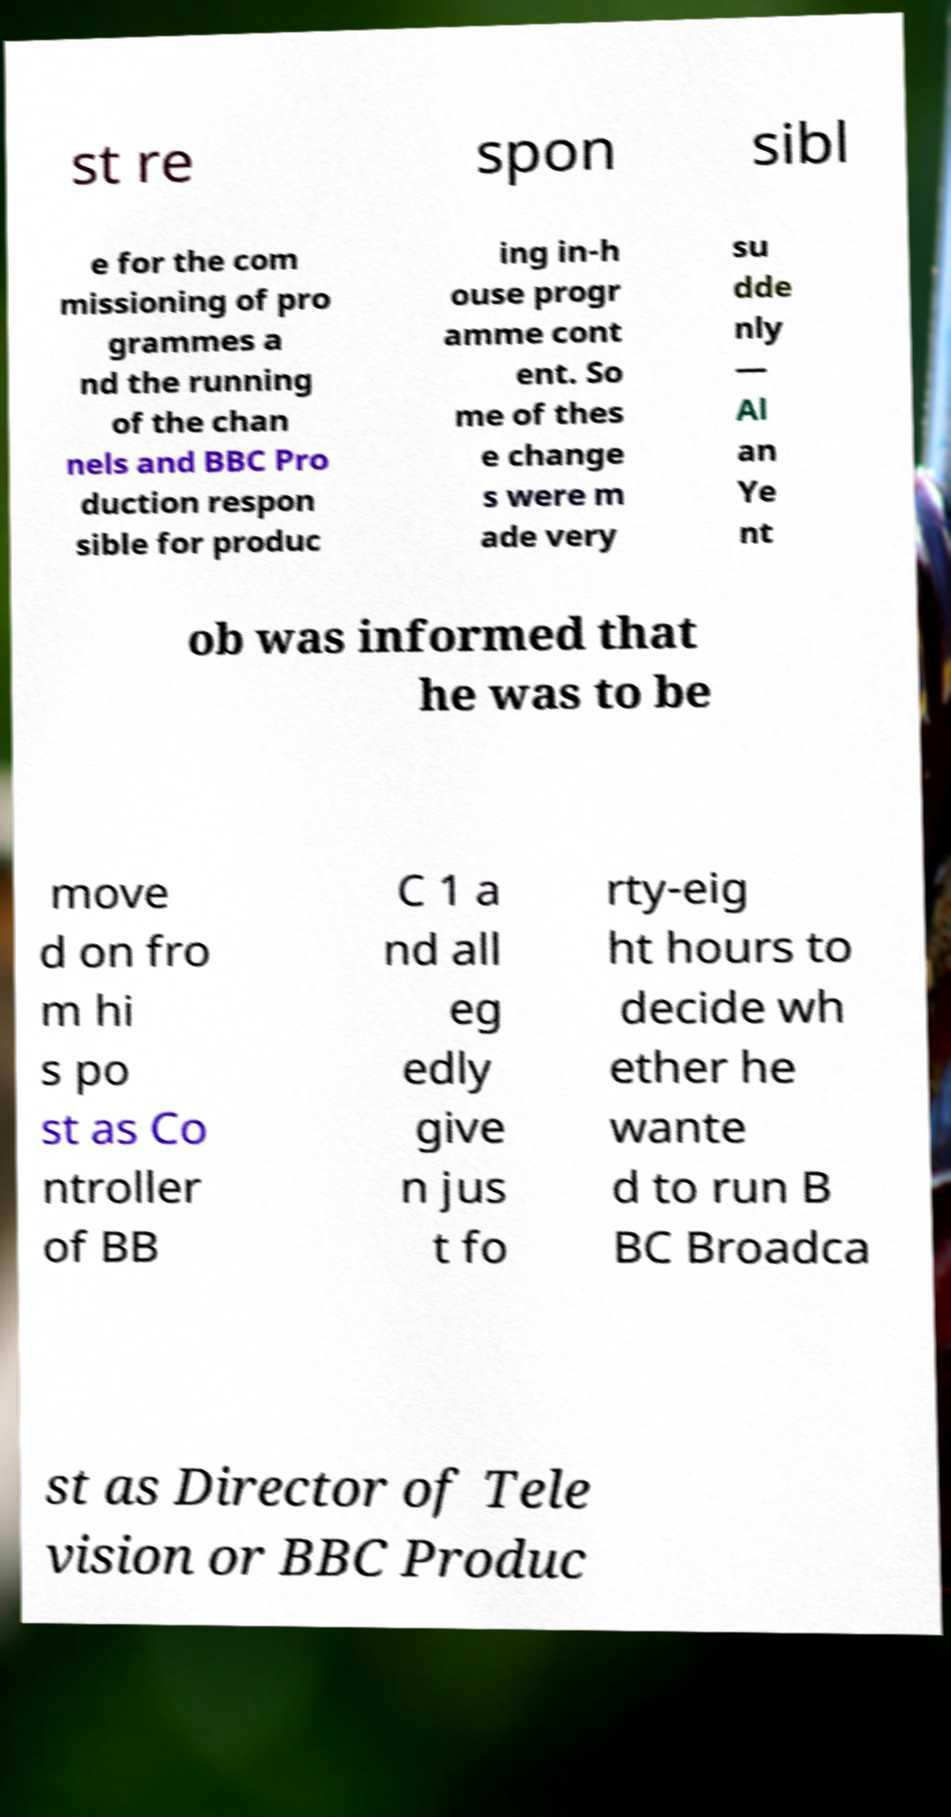Please read and relay the text visible in this image. What does it say? st re spon sibl e for the com missioning of pro grammes a nd the running of the chan nels and BBC Pro duction respon sible for produc ing in-h ouse progr amme cont ent. So me of thes e change s were m ade very su dde nly — Al an Ye nt ob was informed that he was to be move d on fro m hi s po st as Co ntroller of BB C 1 a nd all eg edly give n jus t fo rty-eig ht hours to decide wh ether he wante d to run B BC Broadca st as Director of Tele vision or BBC Produc 